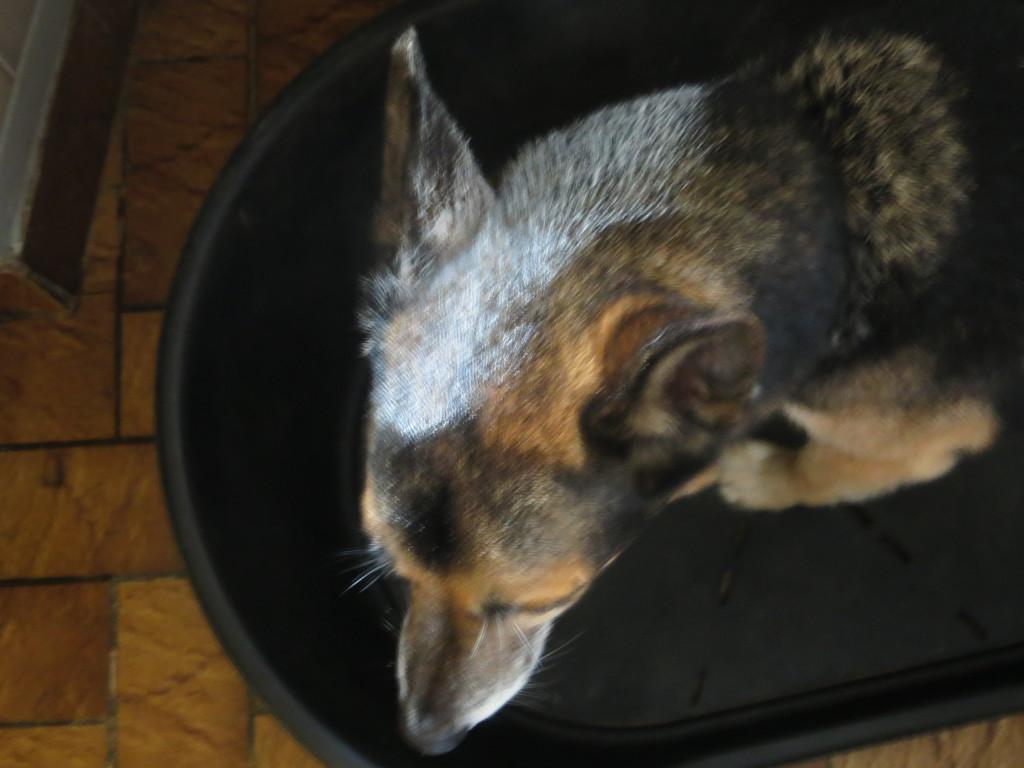What type of living creature is in the image? There is an animal in the image. What is the animal standing or sitting on? The animal is on an object. What can be seen beneath the animal and the object? The ground is visible in the image. What is located in the top left corner of the image? There is an object in the top left corner of the image. How many rabbits are on fire in the image? There are no rabbits or fire present in the image. 